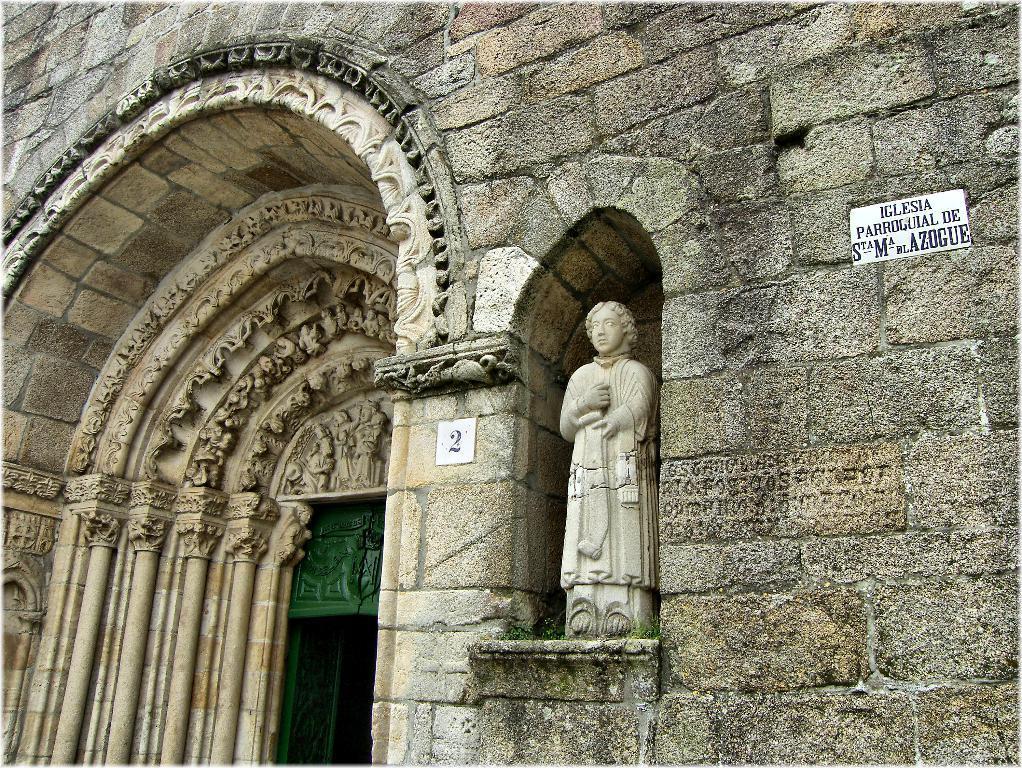Please provide a concise description of this image. This is an outside view of a building. In this image we can see a name board with some text on it, a board with a number on a wall and a statue. 